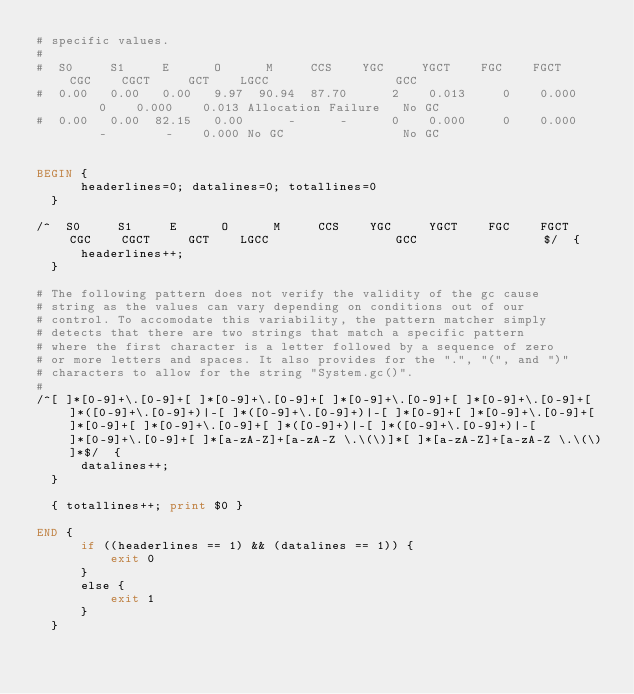Convert code to text. <code><loc_0><loc_0><loc_500><loc_500><_Awk_># specific values.
#
#  S0     S1     E      O      M     CCS    YGC     YGCT    FGC    FGCT     CGC    CGCT     GCT    LGCC                 GCC
#  0.00   0.00   0.00   9.97  90.94  87.70      2    0.013     0    0.000     0    0.000    0.013 Allocation Failure   No GC      
#  0.00   0.00  82.15   0.00      -      -      0    0.000     0    0.000     -        -    0.000 No GC                No GC         


BEGIN	{
	    headerlines=0; datalines=0; totallines=0
	}

/^  S0     S1     E      O      M     CCS    YGC     YGCT    FGC    FGCT    CGC    CGCT     GCT    LGCC                 GCC                 $/	{
	    headerlines++;
	}

# The following pattern does not verify the validity of the gc cause
# string as the values can vary depending on conditions out of our
# control. To accomodate this variability, the pattern matcher simply
# detects that there are two strings that match a specific pattern
# where the first character is a letter followed by a sequence of zero
# or more letters and spaces. It also provides for the ".", "(", and ")"
# characters to allow for the string "System.gc()".
#
/^[ ]*[0-9]+\.[0-9]+[ ]*[0-9]+\.[0-9]+[ ]*[0-9]+\.[0-9]+[ ]*[0-9]+\.[0-9]+[ ]*([0-9]+\.[0-9]+)|-[ ]*([0-9]+\.[0-9]+)|-[ ]*[0-9]+[ ]*[0-9]+\.[0-9]+[ ]*[0-9]+[ ]*[0-9]+\.[0-9]+[ ]*([0-9]+)|-[ ]*([0-9]+\.[0-9]+)|-[ ]*[0-9]+\.[0-9]+[ ]*[a-zA-Z]+[a-zA-Z \.\(\)]*[ ]*[a-zA-Z]+[a-zA-Z \.\(\)]*$/	{
	    datalines++;
	}

	{ totallines++; print $0 }

END	{
	    if ((headerlines == 1) && (datalines == 1)) {
	        exit 0
	    }
	    else {
	        exit 1
	    }
	}
</code> 